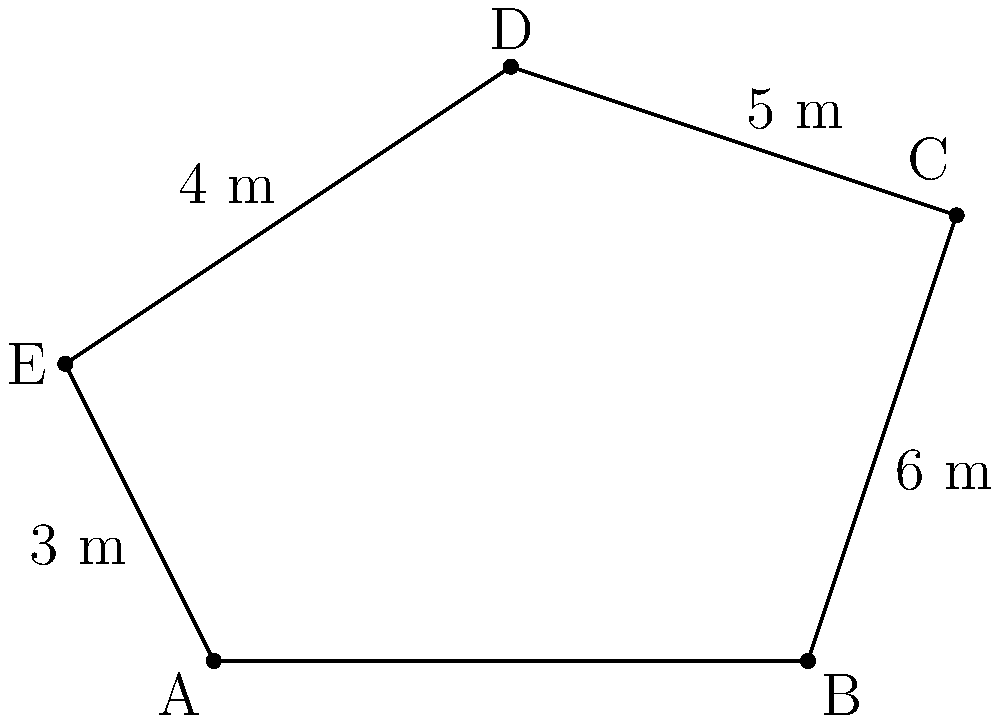In a property dispute case, you're presented with an irregular pentagon ABCDE representing the contested property line. Given that AB = 4 m, BC = 6 m, CD = 5 m, DE = 4 m, and EA = 3 m, what is the total perimeter of the property in meters? To calculate the perimeter of the irregular pentagon, we need to sum up the lengths of all sides:

1. Side AB = 4 m
2. Side BC = 6 m
3. Side CD = 5 m
4. Side DE = 4 m
5. Side EA = 3 m

Now, let's add all these lengths:

$$ \text{Perimeter} = AB + BC + CD + DE + EA $$
$$ \text{Perimeter} = 4 + 6 + 5 + 4 + 3 $$
$$ \text{Perimeter} = 22 \text{ m} $$

Therefore, the total perimeter of the property is 22 meters.
Answer: 22 m 